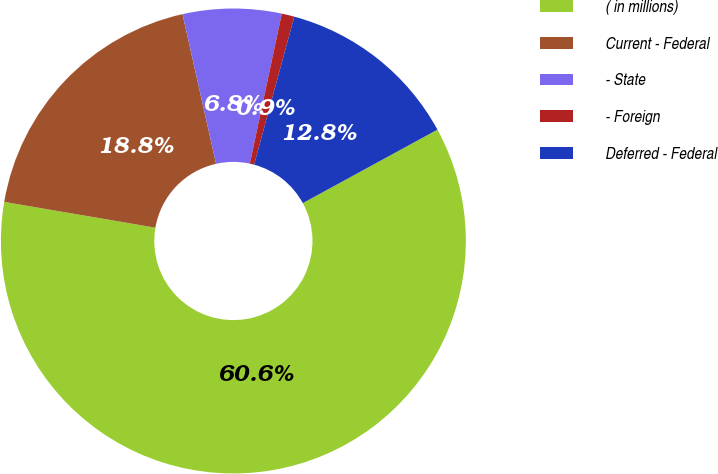Convert chart to OTSL. <chart><loc_0><loc_0><loc_500><loc_500><pie_chart><fcel>( in millions)<fcel>Current - Federal<fcel>- State<fcel>- Foreign<fcel>Deferred - Federal<nl><fcel>60.64%<fcel>18.8%<fcel>6.85%<fcel>0.88%<fcel>12.83%<nl></chart> 